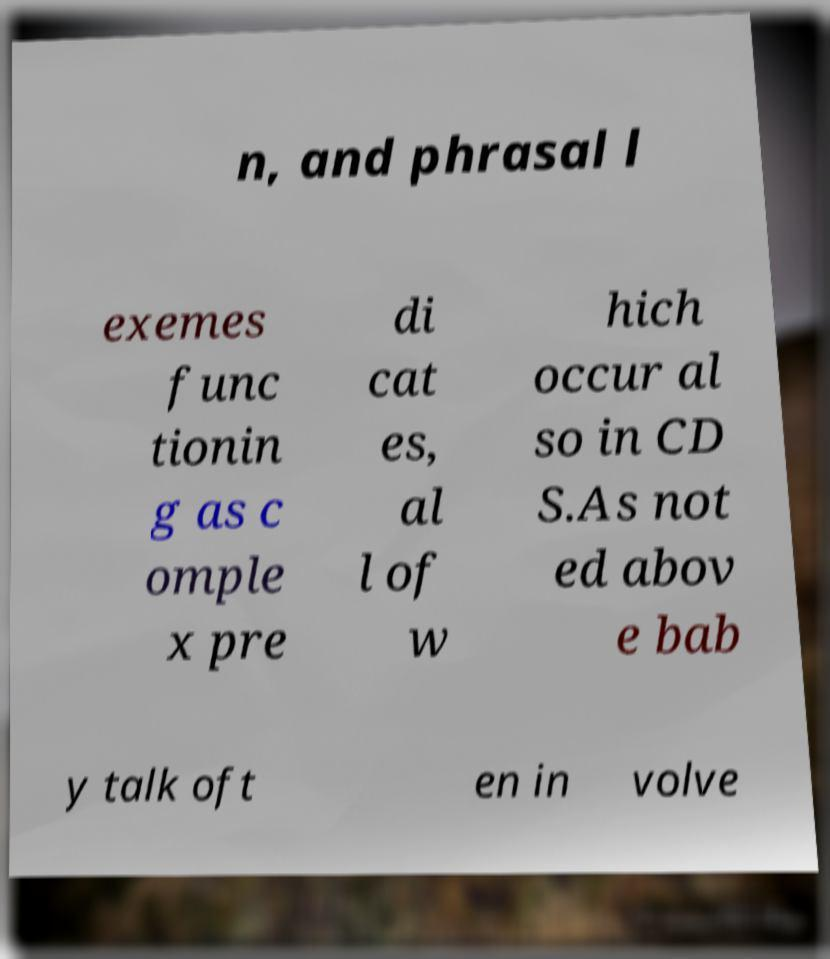Could you assist in decoding the text presented in this image and type it out clearly? n, and phrasal l exemes func tionin g as c omple x pre di cat es, al l of w hich occur al so in CD S.As not ed abov e bab y talk oft en in volve 